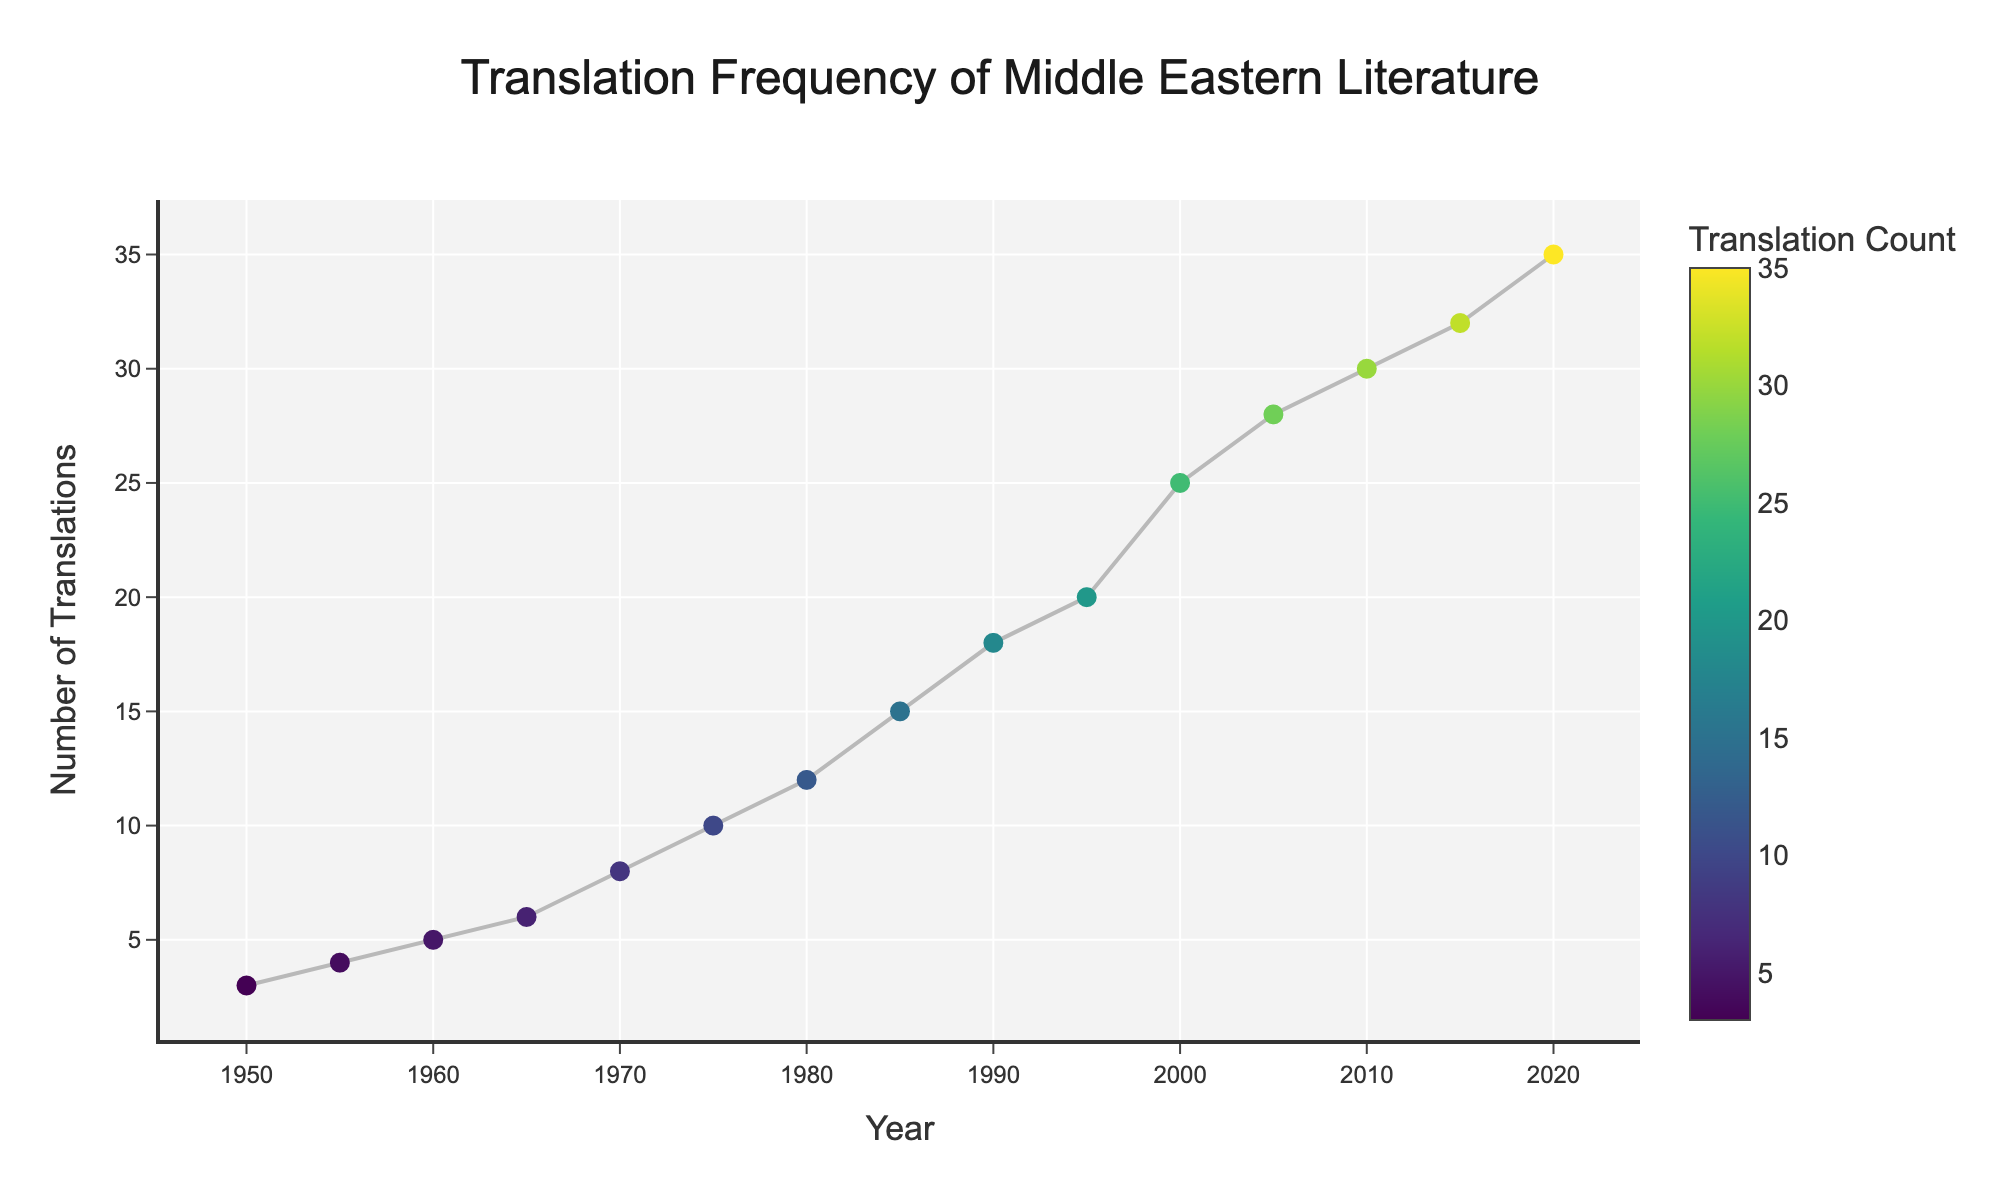What is the title of the plot? The title of the plot is written at the top and it reads "Translation Frequency of Middle Eastern Literature".
Answer: Translation Frequency of Middle Eastern Literature How many authors have their works translated in 1980? The year 1980 corresponds to Mahmoud Darwish in the plot, and the hover information shows a translation count.
Answer: 1 Which author had the highest number of translations in 2020? By looking at the year 2020 on the x-axis, we can see that the author corresponding to that year is Jokha Alharthi.
Answer: Jokha Alharthi What is the number of translations for Orhan Pamuk in 1990? Identify the year 1990 and observe the translation count provided in the hover information for Orhan Pamuk.
Answer: 18 When did the translation count reach 30? Look for the data point where the translation count reaches 30 on the y-axis and note the corresponding year from the x-axis. That year is 2010.
Answer: 2010 Which year saw a higher number of translations: 1980 or 1970? Compare the number of translations between the years 1970 (Ghassan Kanafani with 8 translations) and 1980 (Mahmoud Darwish with 12 translations).
Answer: 1980 What is the average number of translations for the authors listed in the 1960s? The authors from the 1960s are Adonis (5 translations) and Yusuf Idris (6 translations). Calculate the average by adding the two numbers and dividing by 2. (5 + 6) / 2 = 5.5
Answer: 5.5 Is there a period where translations increased exponentially, and if so, when? Observe the trend lines and see where the increases are steep. The period from 2000 to 2020 shows a significant and rapid increase in translation counts.
Answer: 2000 to 2020 What is the total number of translations recorded in the figure? Sum all the translation counts provided for each author: 3 + 5 + 8 + 12 + 18 + 25 + 30 + 35 + 4 + 6 + 10 + 15 + 20 + 28 + 32 = 251
Answer: 251 